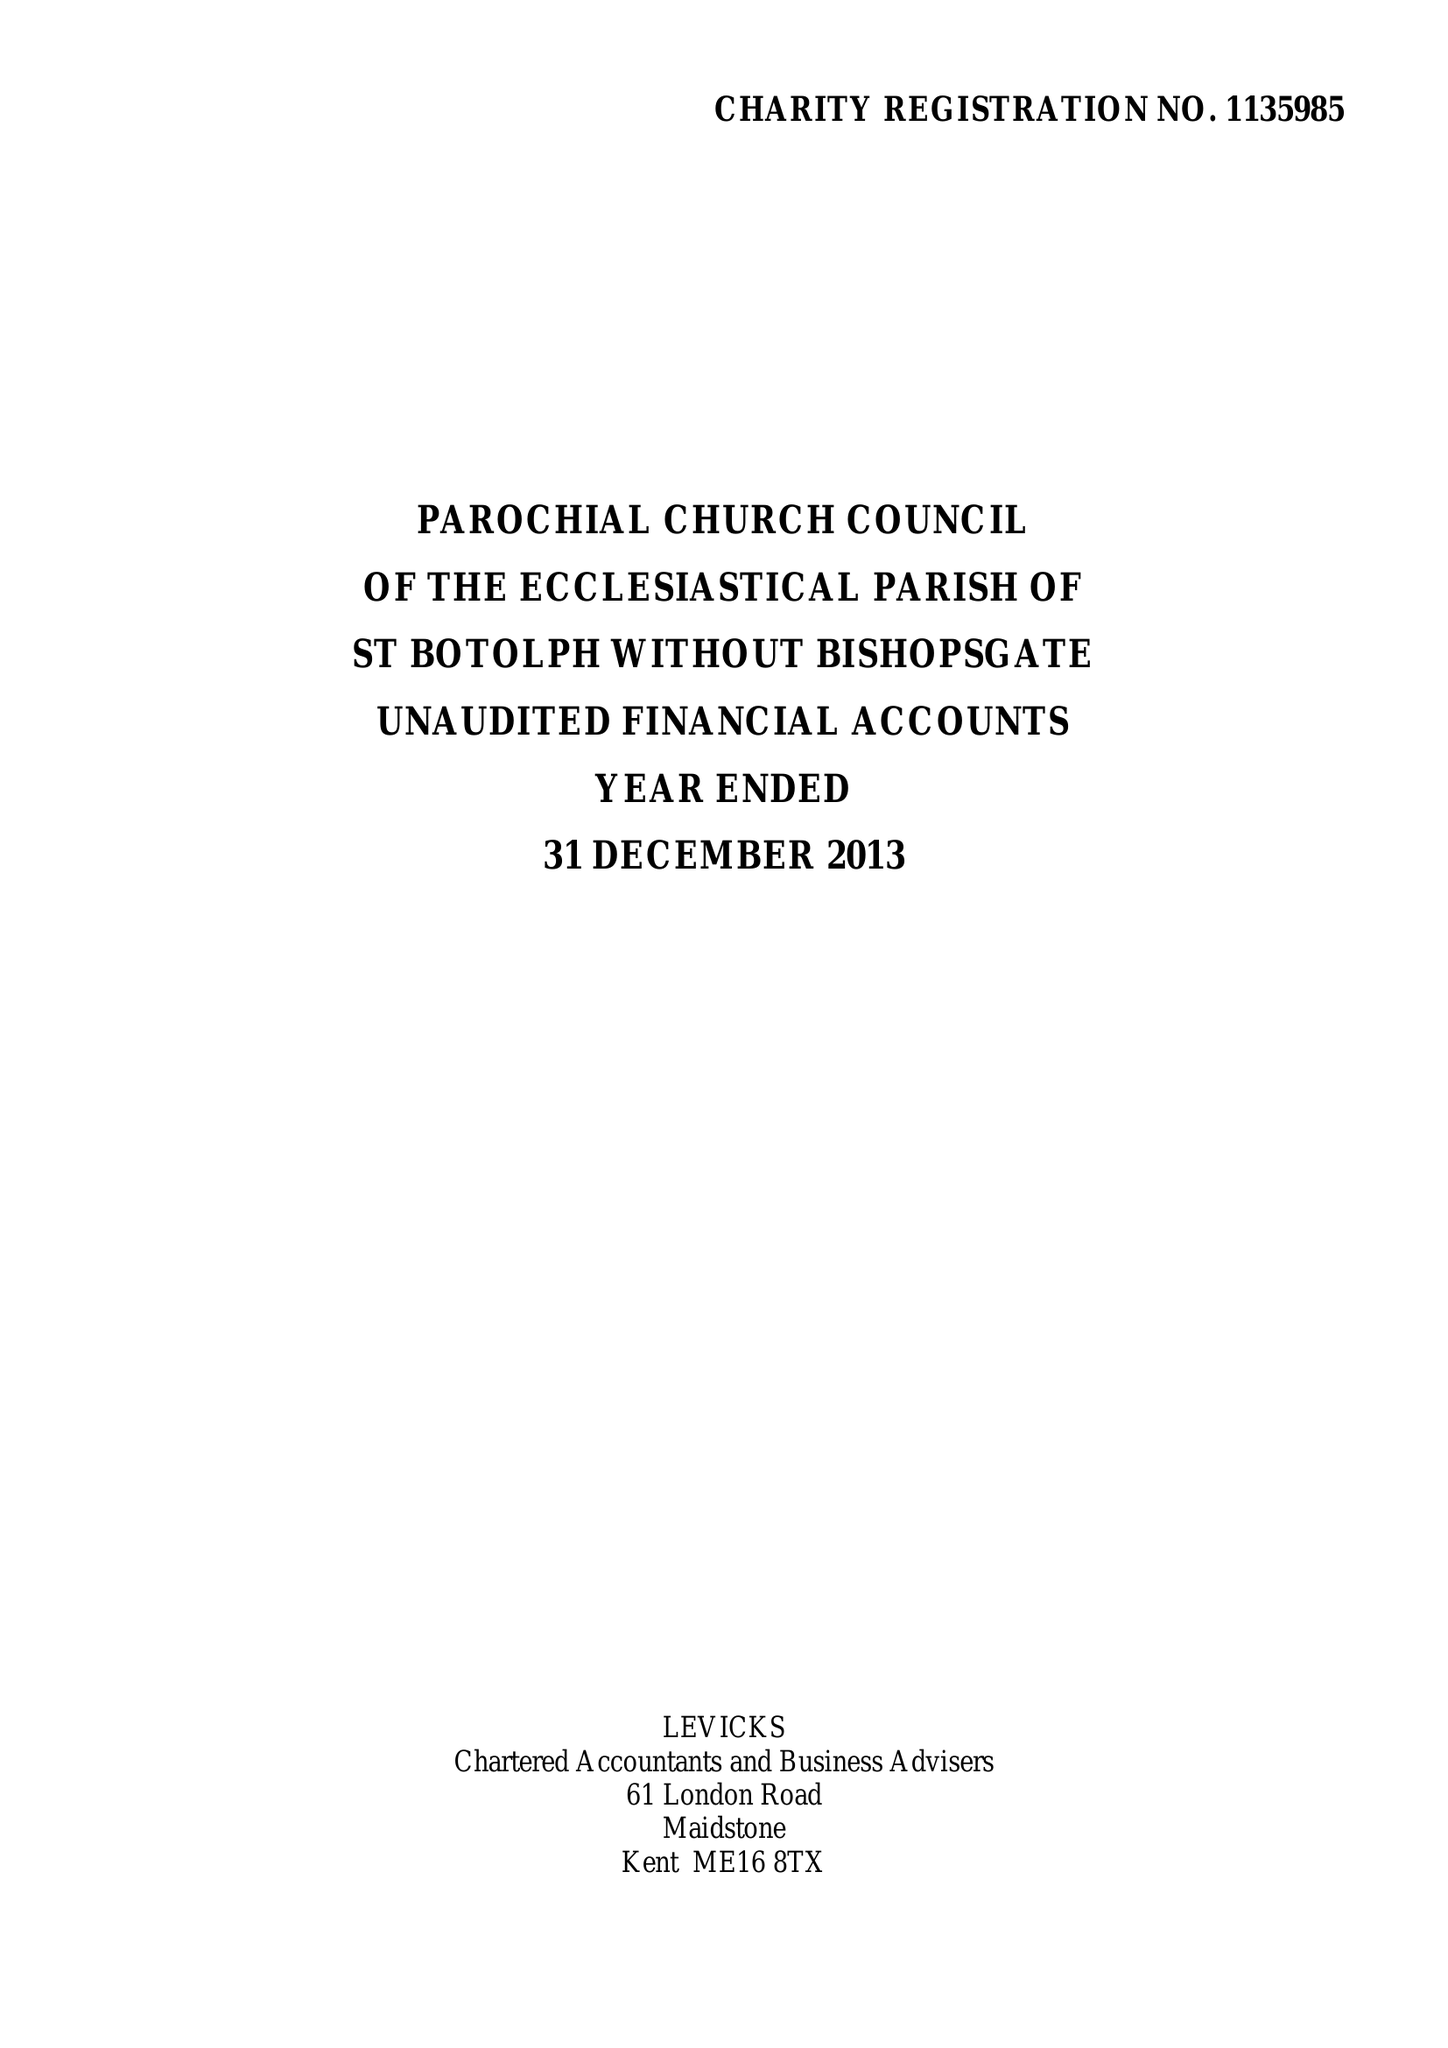What is the value for the spending_annually_in_british_pounds?
Answer the question using a single word or phrase. 294754.00 